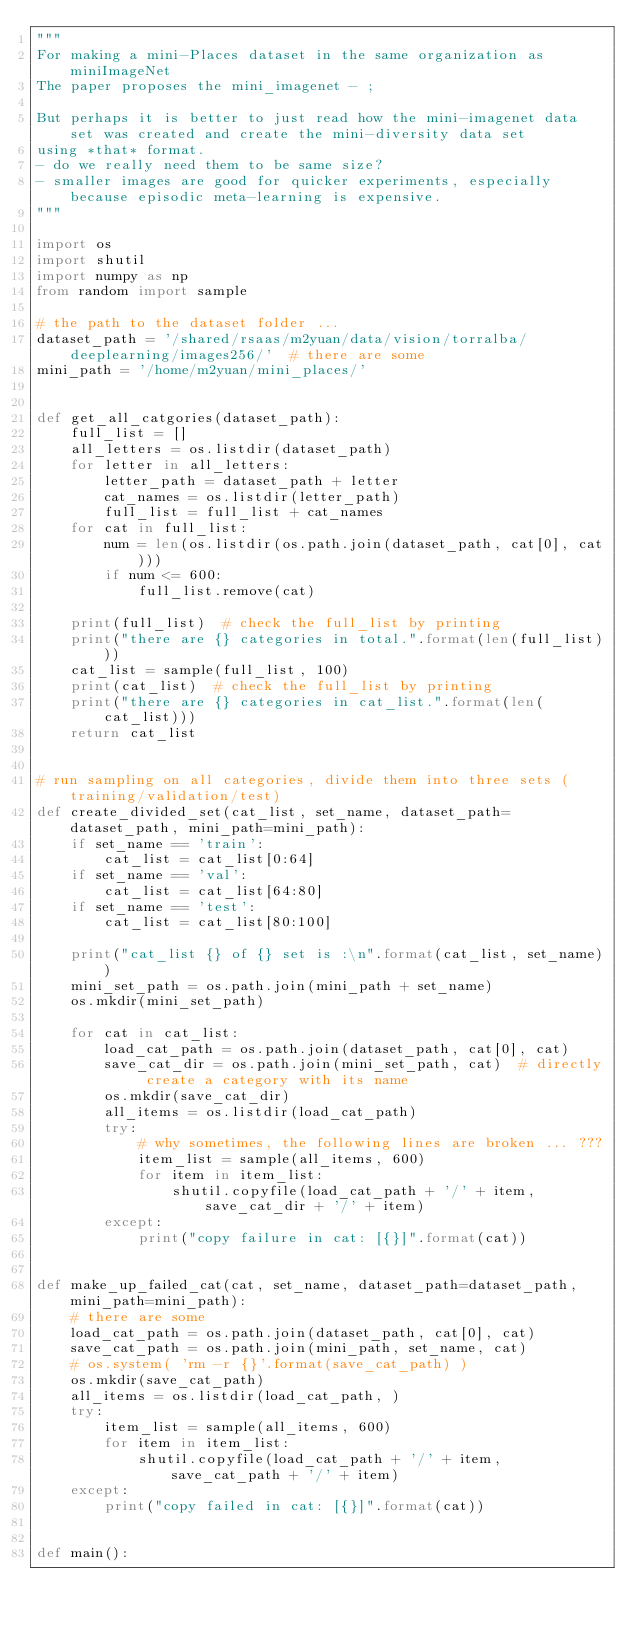Convert code to text. <code><loc_0><loc_0><loc_500><loc_500><_Python_>"""
For making a mini-Places dataset in the same organization as miniImageNet
The paper proposes the mini_imagenet - ;

But perhaps it is better to just read how the mini-imagenet data set was created and create the mini-diversity data set
using *that* format.
- do we really need them to be same size?
- smaller images are good for quicker experiments, especially because episodic meta-learning is expensive.
"""

import os
import shutil
import numpy as np
from random import sample

# the path to the dataset folder ... 
dataset_path = '/shared/rsaas/m2yuan/data/vision/torralba/deeplearning/images256/'  # there are some
mini_path = '/home/m2yuan/mini_places/'


def get_all_catgories(dataset_path):
    full_list = []
    all_letters = os.listdir(dataset_path)
    for letter in all_letters:
        letter_path = dataset_path + letter
        cat_names = os.listdir(letter_path)
        full_list = full_list + cat_names
    for cat in full_list:
        num = len(os.listdir(os.path.join(dataset_path, cat[0], cat)))
        if num <= 600:
            full_list.remove(cat)

    print(full_list)  # check the full_list by printing
    print("there are {} categories in total.".format(len(full_list)))
    cat_list = sample(full_list, 100)
    print(cat_list)  # check the full_list by printing
    print("there are {} categories in cat_list.".format(len(cat_list)))
    return cat_list


# run sampling on all categories, divide them into three sets (training/validation/test)
def create_divided_set(cat_list, set_name, dataset_path=dataset_path, mini_path=mini_path):
    if set_name == 'train':
        cat_list = cat_list[0:64]
    if set_name == 'val':
        cat_list = cat_list[64:80]
    if set_name == 'test':
        cat_list = cat_list[80:100]

    print("cat_list {} of {} set is :\n".format(cat_list, set_name))
    mini_set_path = os.path.join(mini_path + set_name)
    os.mkdir(mini_set_path)

    for cat in cat_list:
        load_cat_path = os.path.join(dataset_path, cat[0], cat)
        save_cat_dir = os.path.join(mini_set_path, cat)  # directly create a category with its name
        os.mkdir(save_cat_dir)
        all_items = os.listdir(load_cat_path)
        try:
            # why sometimes, the following lines are broken ... ??? 
            item_list = sample(all_items, 600)
            for item in item_list:
                shutil.copyfile(load_cat_path + '/' + item, save_cat_dir + '/' + item)
        except:
            print("copy failure in cat: [{}]".format(cat))


def make_up_failed_cat(cat, set_name, dataset_path=dataset_path, mini_path=mini_path):
    # there are some 
    load_cat_path = os.path.join(dataset_path, cat[0], cat)
    save_cat_path = os.path.join(mini_path, set_name, cat)
    # os.system( 'rm -r {}'.format(save_cat_path) )
    os.mkdir(save_cat_path)
    all_items = os.listdir(load_cat_path, )
    try:
        item_list = sample(all_items, 600)
        for item in item_list:
            shutil.copyfile(load_cat_path + '/' + item, save_cat_path + '/' + item)
    except:
        print("copy failed in cat: [{}]".format(cat))


def main():</code> 